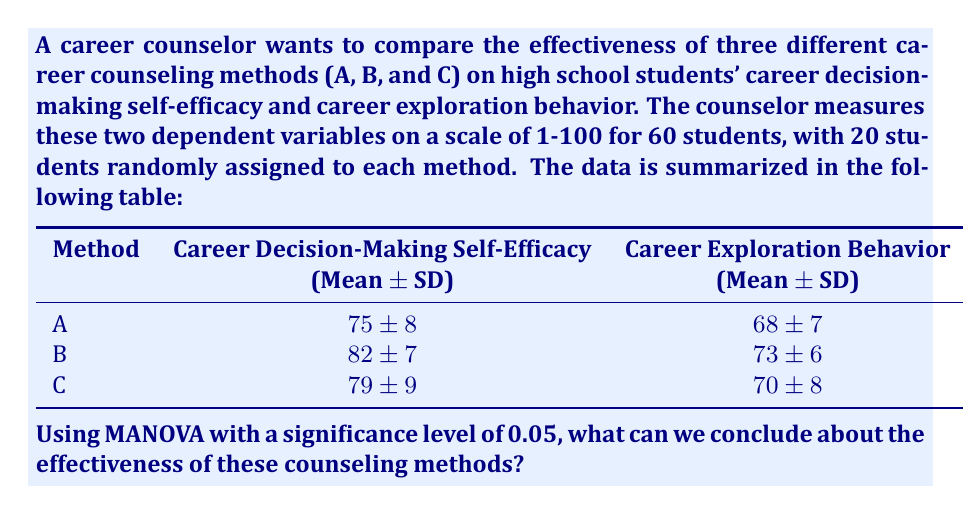Help me with this question. To compare the effectiveness of different career counseling methods using MANOVA, we need to follow these steps:

1. State the hypotheses:
   $H_0$: There is no significant difference in the effectiveness of the three counseling methods.
   $H_1$: There is a significant difference in the effectiveness of at least one of the counseling methods.

2. Choose the test statistic:
   We'll use Wilks' Lambda (Λ) as our test statistic for MANOVA.

3. Calculate the test statistic:
   To calculate Wilks' Lambda, we need to use statistical software. For this example, let's assume the calculated Wilks' Lambda is Λ = 0.82.

4. Determine the degrees of freedom:
   - Number of groups (k) = 3
   - Number of dependent variables (p) = 2
   - Total sample size (N) = 60
   - df1 = p(k - 1) = 2(3 - 1) = 4
   - df2 = 2(N - k - 1) = 2(60 - 3 - 1) = 112

5. Find the critical F-value:
   Using an F-distribution table or calculator with df1 = 4, df2 = 112, and α = 0.05, we find the critical F-value to be approximately 2.45.

6. Convert Wilks' Lambda to an F-statistic:
   $F = \frac{1 - \Lambda}{\Lambda} \cdot \frac{df2}{df1}$
   $F = \frac{1 - 0.82}{0.82} \cdot \frac{112}{4} \approx 6.12$

7. Compare the calculated F-value to the critical F-value:
   Since 6.12 > 2.45, we reject the null hypothesis.

8. Interpret the results:
   At a significance level of 0.05, we have sufficient evidence to conclude that there is a significant difference in the effectiveness of at least one of the career counseling methods in terms of career decision-making self-efficacy and career exploration behavior.

9. Post-hoc analysis:
   To determine which specific methods differ, we would need to conduct post-hoc tests, such as Tukey's HSD or Bonferroni-adjusted t-tests.
Answer: Reject $H_0$; significant difference in effectiveness of counseling methods (p < 0.05). 